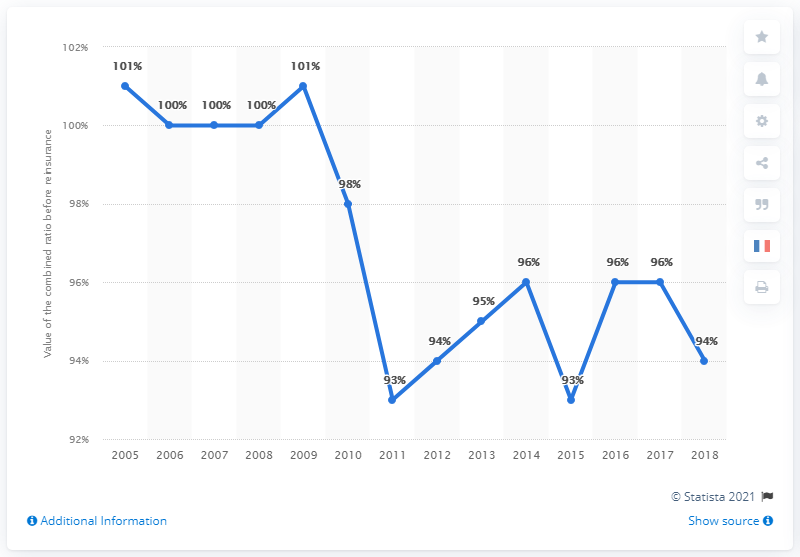Give some essential details in this illustration. The combined ratio of property and liability insurance in France was in 2005. 